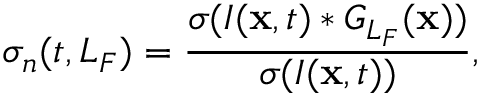Convert formula to latex. <formula><loc_0><loc_0><loc_500><loc_500>\sigma _ { n } ( t , L _ { F } ) = \frac { \sigma ( I ( { x } , t ) * G _ { L _ { F } } ( { x } ) ) } { \sigma ( I ( { x } , t ) ) } ,</formula> 